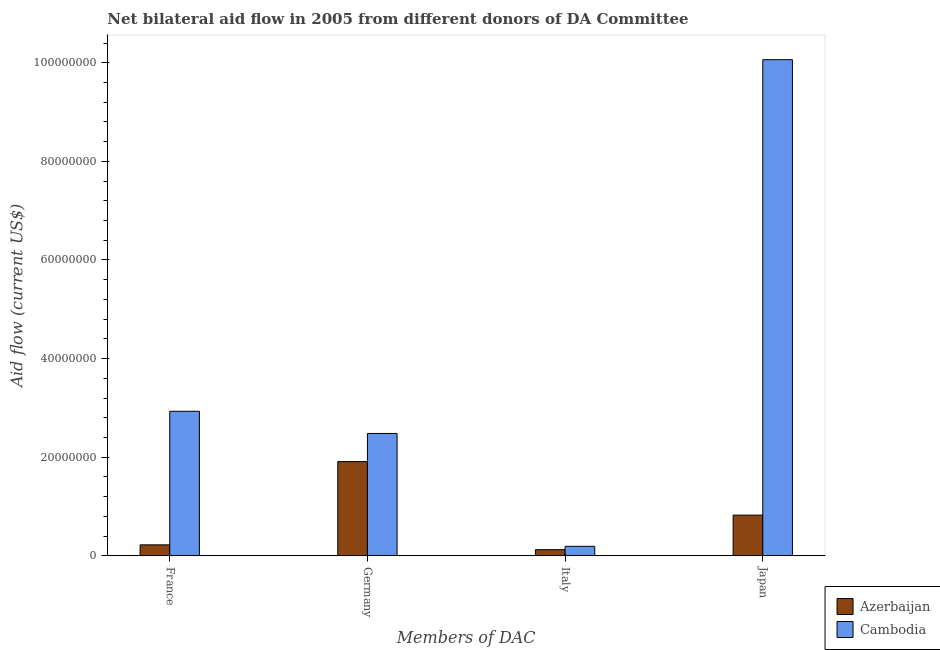How many groups of bars are there?
Offer a very short reply. 4. Are the number of bars on each tick of the X-axis equal?
Keep it short and to the point. Yes. How many bars are there on the 3rd tick from the right?
Ensure brevity in your answer.  2. What is the amount of aid given by italy in Cambodia?
Make the answer very short. 1.92e+06. Across all countries, what is the maximum amount of aid given by japan?
Ensure brevity in your answer.  1.01e+08. Across all countries, what is the minimum amount of aid given by germany?
Offer a very short reply. 1.91e+07. In which country was the amount of aid given by italy maximum?
Your response must be concise. Cambodia. In which country was the amount of aid given by italy minimum?
Offer a very short reply. Azerbaijan. What is the total amount of aid given by italy in the graph?
Offer a terse response. 3.16e+06. What is the difference between the amount of aid given by france in Cambodia and that in Azerbaijan?
Provide a short and direct response. 2.71e+07. What is the difference between the amount of aid given by italy in Azerbaijan and the amount of aid given by france in Cambodia?
Provide a short and direct response. -2.81e+07. What is the average amount of aid given by japan per country?
Your answer should be compact. 5.44e+07. What is the difference between the amount of aid given by italy and amount of aid given by france in Azerbaijan?
Ensure brevity in your answer.  -9.80e+05. What is the ratio of the amount of aid given by japan in Cambodia to that in Azerbaijan?
Give a very brief answer. 12.2. What is the difference between the highest and the second highest amount of aid given by japan?
Make the answer very short. 9.24e+07. What is the difference between the highest and the lowest amount of aid given by france?
Provide a short and direct response. 2.71e+07. Is the sum of the amount of aid given by japan in Cambodia and Azerbaijan greater than the maximum amount of aid given by italy across all countries?
Your answer should be very brief. Yes. Is it the case that in every country, the sum of the amount of aid given by france and amount of aid given by japan is greater than the sum of amount of aid given by italy and amount of aid given by germany?
Give a very brief answer. No. What does the 2nd bar from the left in France represents?
Offer a very short reply. Cambodia. What does the 2nd bar from the right in Japan represents?
Offer a terse response. Azerbaijan. Is it the case that in every country, the sum of the amount of aid given by france and amount of aid given by germany is greater than the amount of aid given by italy?
Offer a very short reply. Yes. Are all the bars in the graph horizontal?
Give a very brief answer. No. How many countries are there in the graph?
Keep it short and to the point. 2. What is the difference between two consecutive major ticks on the Y-axis?
Your answer should be compact. 2.00e+07. Does the graph contain any zero values?
Offer a terse response. No. Does the graph contain grids?
Your response must be concise. No. How many legend labels are there?
Your answer should be very brief. 2. How are the legend labels stacked?
Your response must be concise. Vertical. What is the title of the graph?
Your response must be concise. Net bilateral aid flow in 2005 from different donors of DA Committee. Does "Azerbaijan" appear as one of the legend labels in the graph?
Your answer should be compact. Yes. What is the label or title of the X-axis?
Make the answer very short. Members of DAC. What is the label or title of the Y-axis?
Ensure brevity in your answer.  Aid flow (current US$). What is the Aid flow (current US$) of Azerbaijan in France?
Give a very brief answer. 2.22e+06. What is the Aid flow (current US$) of Cambodia in France?
Make the answer very short. 2.93e+07. What is the Aid flow (current US$) in Azerbaijan in Germany?
Your answer should be compact. 1.91e+07. What is the Aid flow (current US$) in Cambodia in Germany?
Offer a terse response. 2.48e+07. What is the Aid flow (current US$) in Azerbaijan in Italy?
Provide a succinct answer. 1.24e+06. What is the Aid flow (current US$) in Cambodia in Italy?
Give a very brief answer. 1.92e+06. What is the Aid flow (current US$) of Azerbaijan in Japan?
Your answer should be compact. 8.25e+06. What is the Aid flow (current US$) of Cambodia in Japan?
Your response must be concise. 1.01e+08. Across all Members of DAC, what is the maximum Aid flow (current US$) of Azerbaijan?
Offer a terse response. 1.91e+07. Across all Members of DAC, what is the maximum Aid flow (current US$) of Cambodia?
Provide a short and direct response. 1.01e+08. Across all Members of DAC, what is the minimum Aid flow (current US$) of Azerbaijan?
Provide a succinct answer. 1.24e+06. Across all Members of DAC, what is the minimum Aid flow (current US$) of Cambodia?
Your answer should be very brief. 1.92e+06. What is the total Aid flow (current US$) of Azerbaijan in the graph?
Ensure brevity in your answer.  3.08e+07. What is the total Aid flow (current US$) in Cambodia in the graph?
Provide a succinct answer. 1.57e+08. What is the difference between the Aid flow (current US$) of Azerbaijan in France and that in Germany?
Give a very brief answer. -1.69e+07. What is the difference between the Aid flow (current US$) of Cambodia in France and that in Germany?
Offer a very short reply. 4.50e+06. What is the difference between the Aid flow (current US$) in Azerbaijan in France and that in Italy?
Your response must be concise. 9.80e+05. What is the difference between the Aid flow (current US$) of Cambodia in France and that in Italy?
Keep it short and to the point. 2.74e+07. What is the difference between the Aid flow (current US$) of Azerbaijan in France and that in Japan?
Offer a very short reply. -6.03e+06. What is the difference between the Aid flow (current US$) in Cambodia in France and that in Japan?
Give a very brief answer. -7.13e+07. What is the difference between the Aid flow (current US$) in Azerbaijan in Germany and that in Italy?
Keep it short and to the point. 1.79e+07. What is the difference between the Aid flow (current US$) of Cambodia in Germany and that in Italy?
Give a very brief answer. 2.29e+07. What is the difference between the Aid flow (current US$) in Azerbaijan in Germany and that in Japan?
Offer a terse response. 1.09e+07. What is the difference between the Aid flow (current US$) in Cambodia in Germany and that in Japan?
Give a very brief answer. -7.58e+07. What is the difference between the Aid flow (current US$) of Azerbaijan in Italy and that in Japan?
Keep it short and to the point. -7.01e+06. What is the difference between the Aid flow (current US$) in Cambodia in Italy and that in Japan?
Your answer should be compact. -9.87e+07. What is the difference between the Aid flow (current US$) in Azerbaijan in France and the Aid flow (current US$) in Cambodia in Germany?
Offer a terse response. -2.26e+07. What is the difference between the Aid flow (current US$) of Azerbaijan in France and the Aid flow (current US$) of Cambodia in Japan?
Ensure brevity in your answer.  -9.84e+07. What is the difference between the Aid flow (current US$) of Azerbaijan in Germany and the Aid flow (current US$) of Cambodia in Italy?
Your answer should be compact. 1.72e+07. What is the difference between the Aid flow (current US$) in Azerbaijan in Germany and the Aid flow (current US$) in Cambodia in Japan?
Your answer should be very brief. -8.15e+07. What is the difference between the Aid flow (current US$) in Azerbaijan in Italy and the Aid flow (current US$) in Cambodia in Japan?
Your answer should be very brief. -9.94e+07. What is the average Aid flow (current US$) of Azerbaijan per Members of DAC?
Provide a succinct answer. 7.70e+06. What is the average Aid flow (current US$) in Cambodia per Members of DAC?
Your answer should be compact. 3.92e+07. What is the difference between the Aid flow (current US$) in Azerbaijan and Aid flow (current US$) in Cambodia in France?
Provide a short and direct response. -2.71e+07. What is the difference between the Aid flow (current US$) of Azerbaijan and Aid flow (current US$) of Cambodia in Germany?
Provide a succinct answer. -5.70e+06. What is the difference between the Aid flow (current US$) in Azerbaijan and Aid flow (current US$) in Cambodia in Italy?
Ensure brevity in your answer.  -6.80e+05. What is the difference between the Aid flow (current US$) of Azerbaijan and Aid flow (current US$) of Cambodia in Japan?
Your answer should be very brief. -9.24e+07. What is the ratio of the Aid flow (current US$) of Azerbaijan in France to that in Germany?
Provide a succinct answer. 0.12. What is the ratio of the Aid flow (current US$) in Cambodia in France to that in Germany?
Keep it short and to the point. 1.18. What is the ratio of the Aid flow (current US$) in Azerbaijan in France to that in Italy?
Keep it short and to the point. 1.79. What is the ratio of the Aid flow (current US$) of Cambodia in France to that in Italy?
Your answer should be compact. 15.27. What is the ratio of the Aid flow (current US$) of Azerbaijan in France to that in Japan?
Ensure brevity in your answer.  0.27. What is the ratio of the Aid flow (current US$) in Cambodia in France to that in Japan?
Ensure brevity in your answer.  0.29. What is the ratio of the Aid flow (current US$) of Azerbaijan in Germany to that in Italy?
Provide a succinct answer. 15.41. What is the ratio of the Aid flow (current US$) in Cambodia in Germany to that in Italy?
Make the answer very short. 12.92. What is the ratio of the Aid flow (current US$) in Azerbaijan in Germany to that in Japan?
Make the answer very short. 2.32. What is the ratio of the Aid flow (current US$) of Cambodia in Germany to that in Japan?
Your response must be concise. 0.25. What is the ratio of the Aid flow (current US$) of Azerbaijan in Italy to that in Japan?
Ensure brevity in your answer.  0.15. What is the ratio of the Aid flow (current US$) in Cambodia in Italy to that in Japan?
Your answer should be very brief. 0.02. What is the difference between the highest and the second highest Aid flow (current US$) of Azerbaijan?
Provide a succinct answer. 1.09e+07. What is the difference between the highest and the second highest Aid flow (current US$) in Cambodia?
Your response must be concise. 7.13e+07. What is the difference between the highest and the lowest Aid flow (current US$) in Azerbaijan?
Your answer should be very brief. 1.79e+07. What is the difference between the highest and the lowest Aid flow (current US$) of Cambodia?
Your answer should be compact. 9.87e+07. 